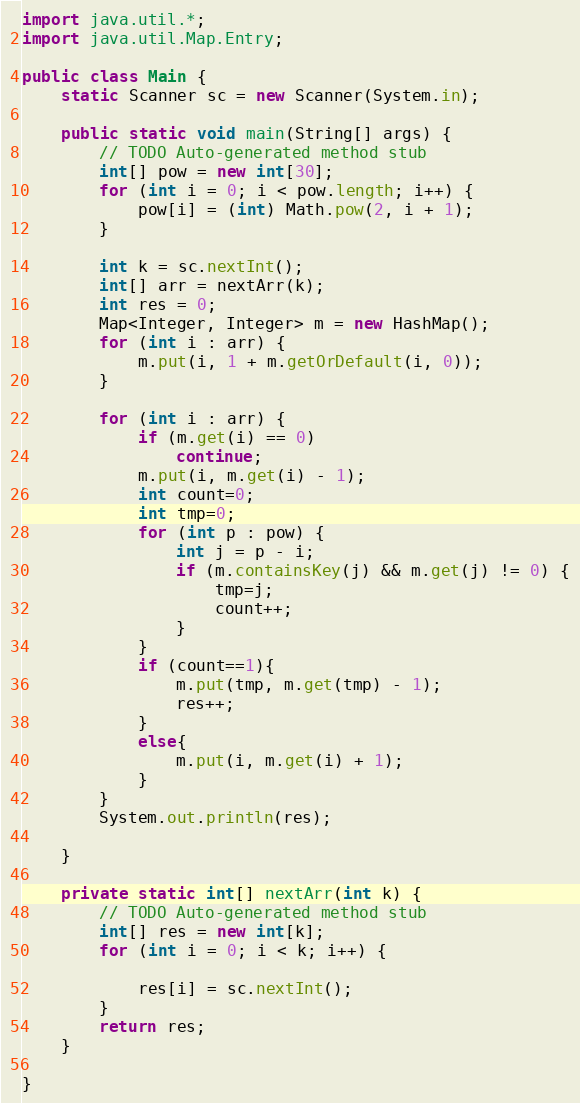Convert code to text. <code><loc_0><loc_0><loc_500><loc_500><_Java_>import java.util.*;
import java.util.Map.Entry;

public class Main {
	static Scanner sc = new Scanner(System.in);

	public static void main(String[] args) {
		// TODO Auto-generated method stub
		int[] pow = new int[30];
		for (int i = 0; i < pow.length; i++) {
			pow[i] = (int) Math.pow(2, i + 1);
		}

		int k = sc.nextInt();
		int[] arr = nextArr(k);
		int res = 0;
		Map<Integer, Integer> m = new HashMap();
		for (int i : arr) {
			m.put(i, 1 + m.getOrDefault(i, 0));
		}

		for (int i : arr) {
			if (m.get(i) == 0)
				continue;
			m.put(i, m.get(i) - 1);
			int count=0;
			int tmp=0;
			for (int p : pow) {
				int j = p - i;
				if (m.containsKey(j) && m.get(j) != 0) {
					tmp=j;
					count++;
				}
			}
			if (count==1){
				m.put(tmp, m.get(tmp) - 1);
				res++;
			}
			else{
				m.put(i, m.get(i) + 1);
			}
		}
		System.out.println(res);

	}

	private static int[] nextArr(int k) {
		// TODO Auto-generated method stub
		int[] res = new int[k];
		for (int i = 0; i < k; i++) {

			res[i] = sc.nextInt();
		}
		return res;
	}

}
</code> 